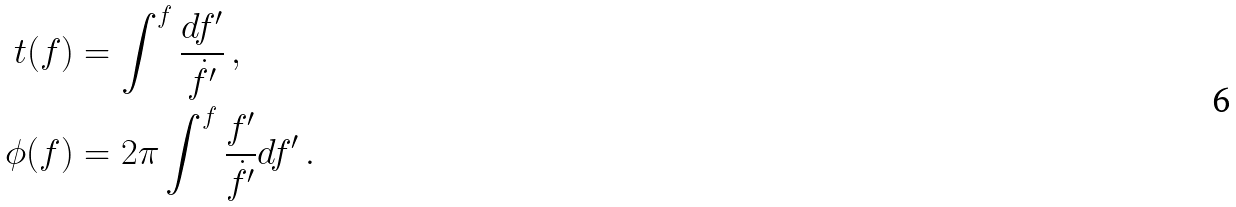<formula> <loc_0><loc_0><loc_500><loc_500>t ( f ) & = \int ^ { f } \frac { d f ^ { \prime } } { { \dot { f } } ^ { \prime } } \, , \\ \phi ( f ) & = 2 \pi \int ^ { f } \frac { f ^ { \prime } } { { \dot { f } } ^ { \prime } } d f ^ { \prime } \, .</formula> 